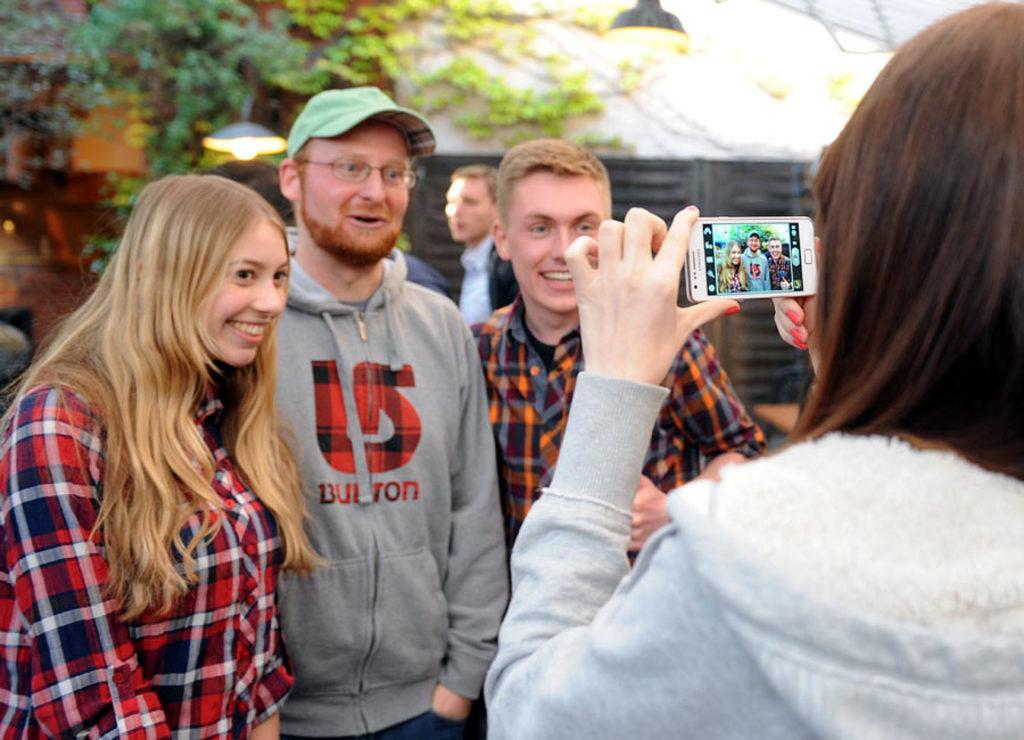Please provide a concise description of this image. In front of the image there is a person holding the mobile. In front of her there are three people having a smile on their faces. Behind them there are a few other people standing. In the background of the image there are lamps, trees and a building. 